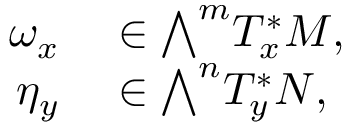<formula> <loc_0><loc_0><loc_500><loc_500>\begin{array} { r l } { \omega _ { x } } & \in { \bigwedge } ^ { m } T _ { x } ^ { * } M , } \\ { \eta _ { y } } & \in { \bigwedge } ^ { n } T _ { y } ^ { * } N , } \end{array}</formula> 